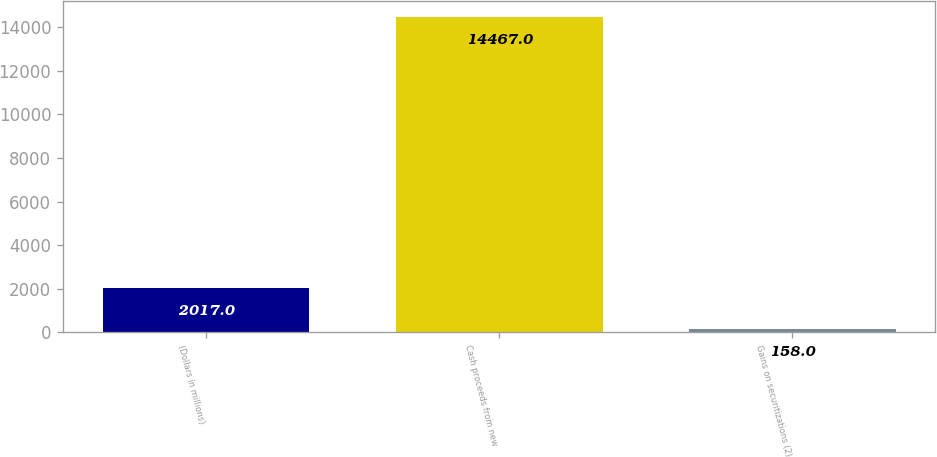<chart> <loc_0><loc_0><loc_500><loc_500><bar_chart><fcel>(Dollars in millions)<fcel>Cash proceeds from new<fcel>Gains on securitizations (2)<nl><fcel>2017<fcel>14467<fcel>158<nl></chart> 